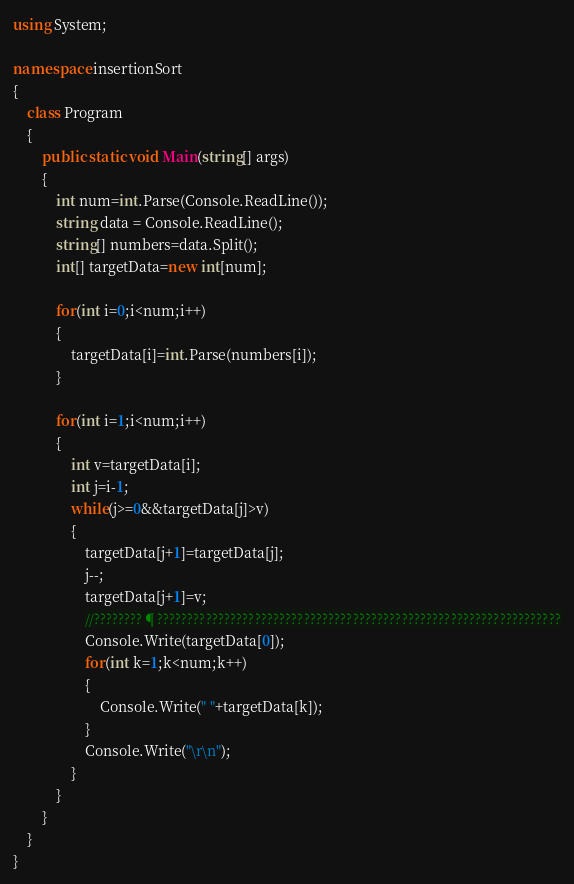Convert code to text. <code><loc_0><loc_0><loc_500><loc_500><_C#_>
using System;

namespace insertionSort
{
	class Program
	{
		public static void Main(string[] args)
		{
			int num=int.Parse(Console.ReadLine());
			string data = Console.ReadLine();
			string[] numbers=data.Split();
			int[] targetData=new int[num];
				
			for(int i=0;i<num;i++)
			{
				targetData[i]=int.Parse(numbers[i]);
			}
			
			for(int i=1;i<num;i++)
			{
				int v=targetData[i];
				int j=i-1;
				while(j>=0&&targetData[j]>v)
				{
					targetData[j+1]=targetData[j];
					j--;
					targetData[j+1]=v;
					//????????¶??????????????????????????????????????????????????????????????????
					Console.Write(targetData[0]);
					for(int k=1;k<num;k++)
					{
						Console.Write(" "+targetData[k]);
					}
					Console.Write("\r\n");
				}
			}
		}
	}
}</code> 